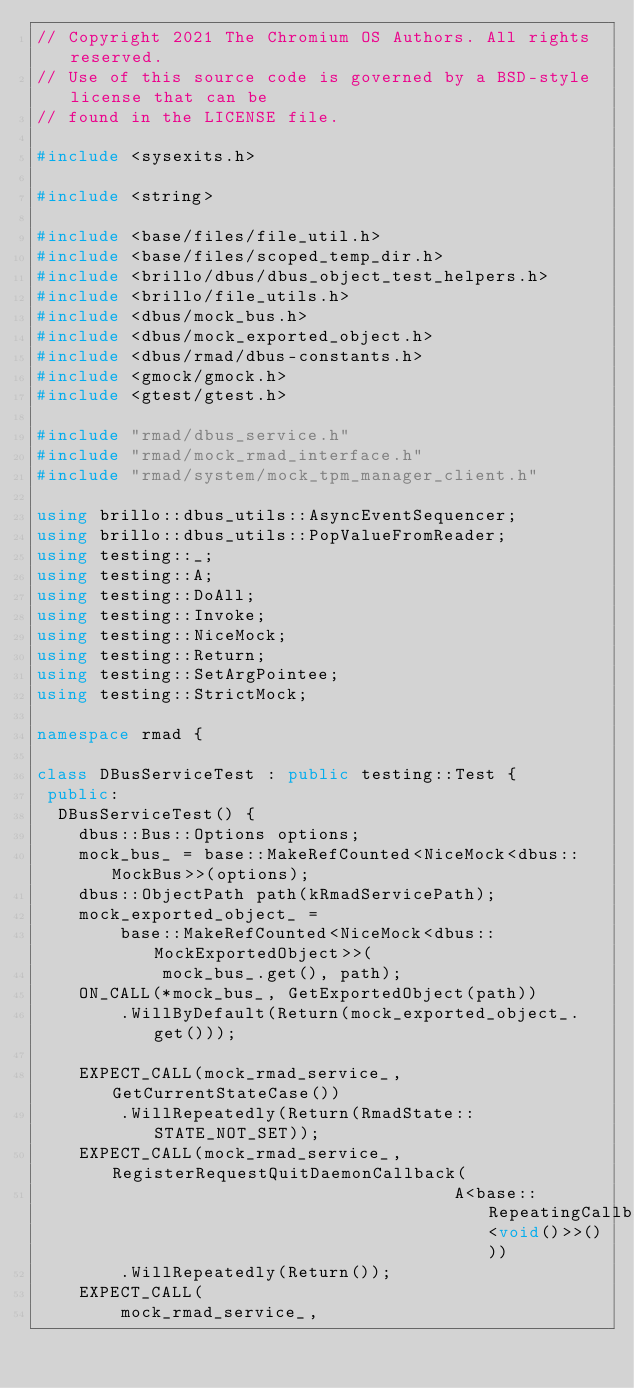<code> <loc_0><loc_0><loc_500><loc_500><_C++_>// Copyright 2021 The Chromium OS Authors. All rights reserved.
// Use of this source code is governed by a BSD-style license that can be
// found in the LICENSE file.

#include <sysexits.h>

#include <string>

#include <base/files/file_util.h>
#include <base/files/scoped_temp_dir.h>
#include <brillo/dbus/dbus_object_test_helpers.h>
#include <brillo/file_utils.h>
#include <dbus/mock_bus.h>
#include <dbus/mock_exported_object.h>
#include <dbus/rmad/dbus-constants.h>
#include <gmock/gmock.h>
#include <gtest/gtest.h>

#include "rmad/dbus_service.h"
#include "rmad/mock_rmad_interface.h"
#include "rmad/system/mock_tpm_manager_client.h"

using brillo::dbus_utils::AsyncEventSequencer;
using brillo::dbus_utils::PopValueFromReader;
using testing::_;
using testing::A;
using testing::DoAll;
using testing::Invoke;
using testing::NiceMock;
using testing::Return;
using testing::SetArgPointee;
using testing::StrictMock;

namespace rmad {

class DBusServiceTest : public testing::Test {
 public:
  DBusServiceTest() {
    dbus::Bus::Options options;
    mock_bus_ = base::MakeRefCounted<NiceMock<dbus::MockBus>>(options);
    dbus::ObjectPath path(kRmadServicePath);
    mock_exported_object_ =
        base::MakeRefCounted<NiceMock<dbus::MockExportedObject>>(
            mock_bus_.get(), path);
    ON_CALL(*mock_bus_, GetExportedObject(path))
        .WillByDefault(Return(mock_exported_object_.get()));

    EXPECT_CALL(mock_rmad_service_, GetCurrentStateCase())
        .WillRepeatedly(Return(RmadState::STATE_NOT_SET));
    EXPECT_CALL(mock_rmad_service_, RegisterRequestQuitDaemonCallback(
                                        A<base::RepeatingCallback<void()>>()))
        .WillRepeatedly(Return());
    EXPECT_CALL(
        mock_rmad_service_,</code> 